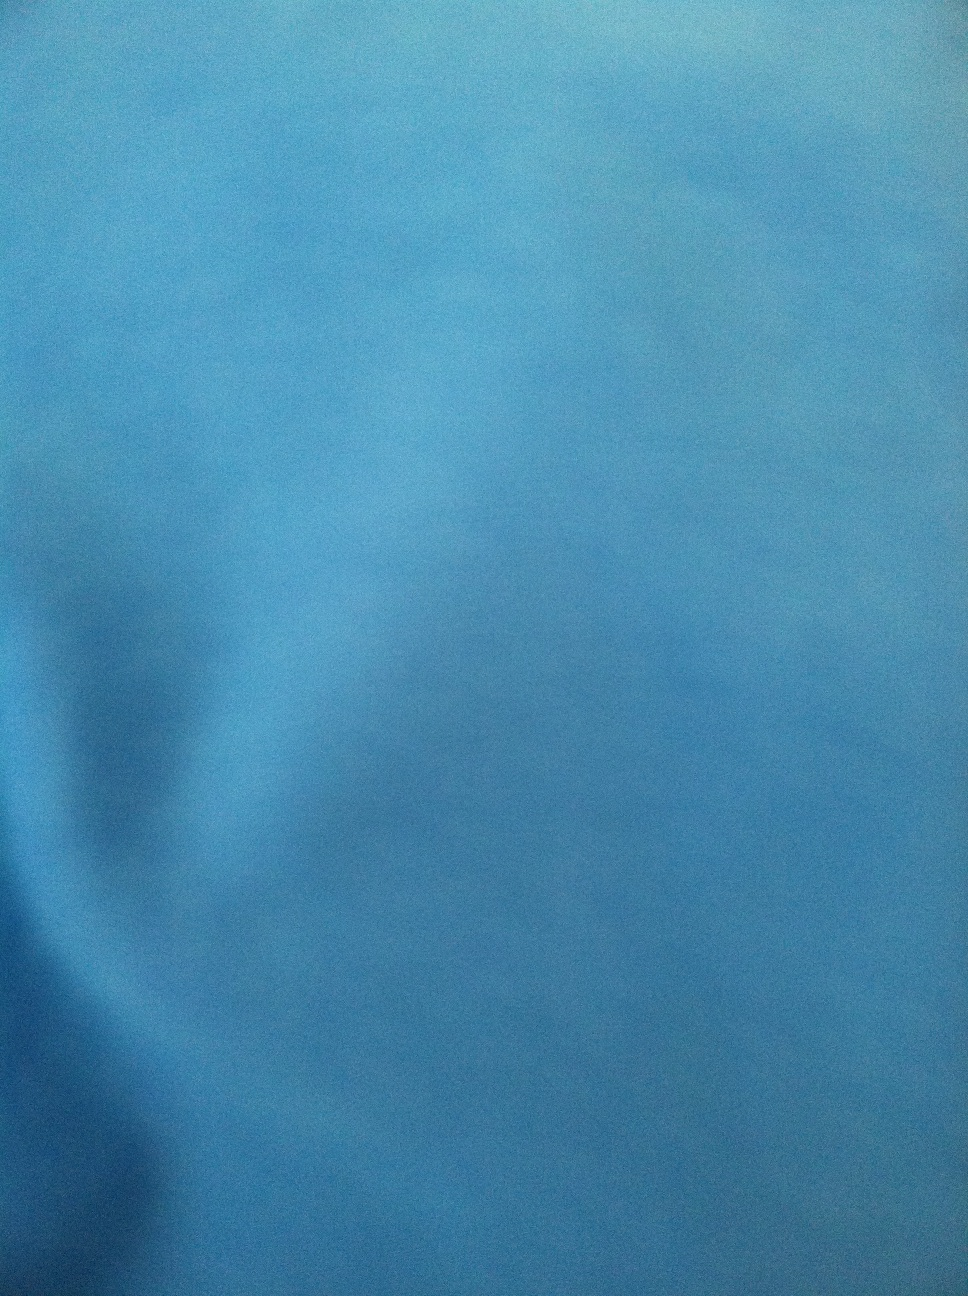Please tell me what color this dress is, thank you from Vizwiz The dress in the image you provided is a lovely shade of blue. This color can vary depending on lighting conditions, but from what we see here, it's predominantly blue. 